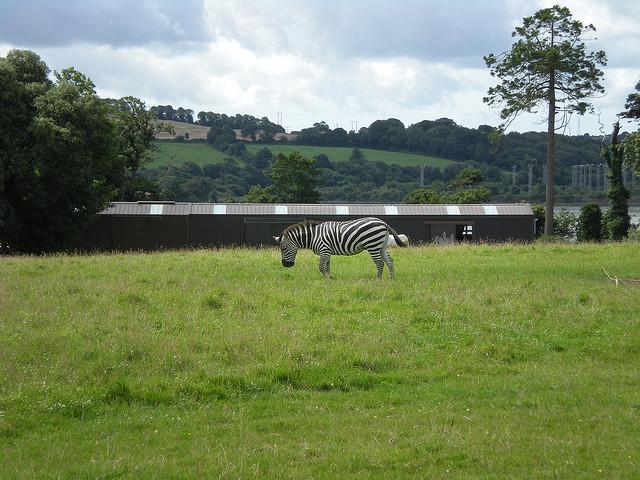How many animals are seen?
Give a very brief answer. 1. How many bears are there in the picture?
Give a very brief answer. 0. 